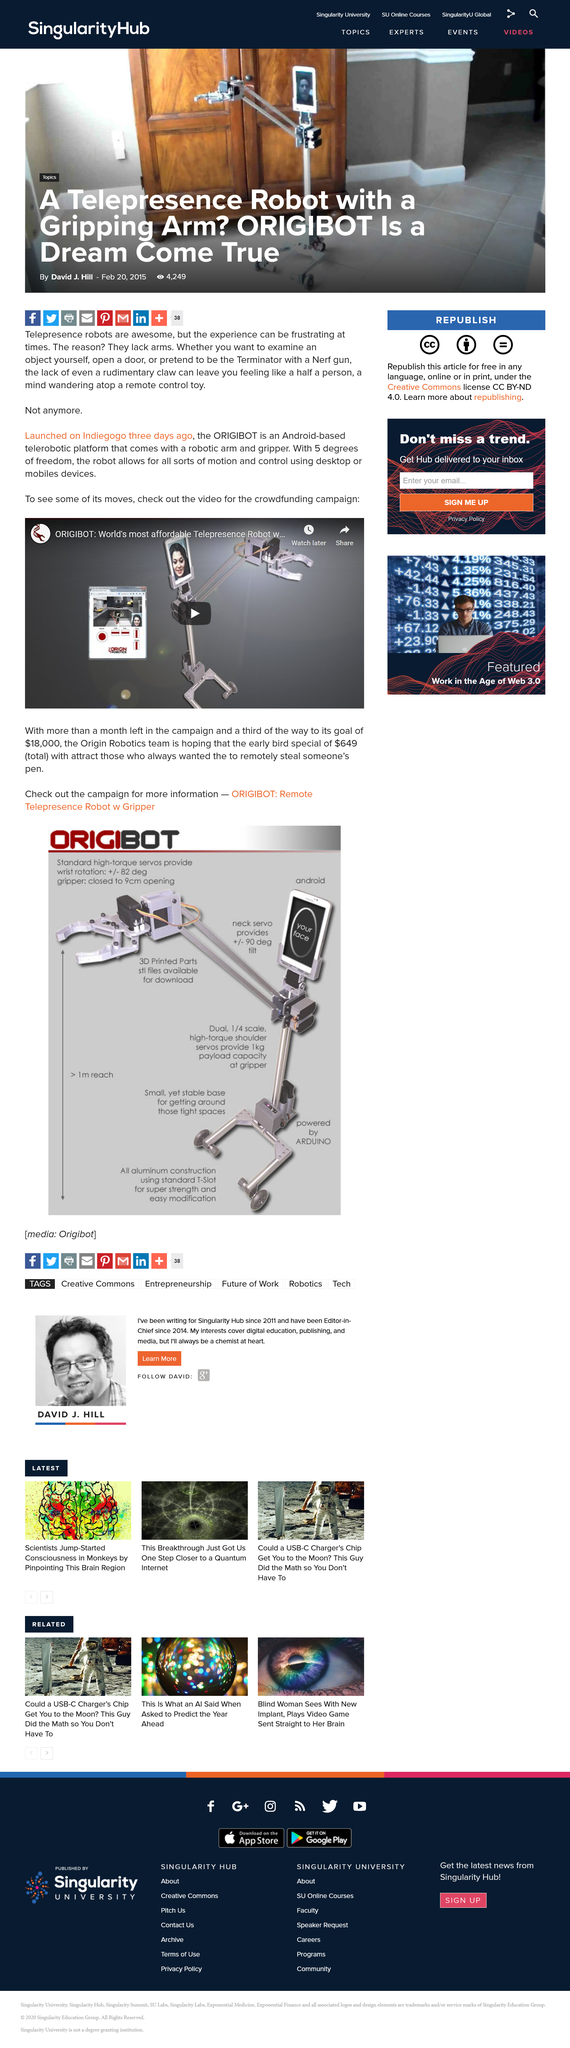Draw attention to some important aspects in this diagram. The Origibot is an Android-based tele-robotic platform equipped with a robotic arm and gripper, designed for a wide range of industrial and research applications. The Origibot early bird special is available for $649. 